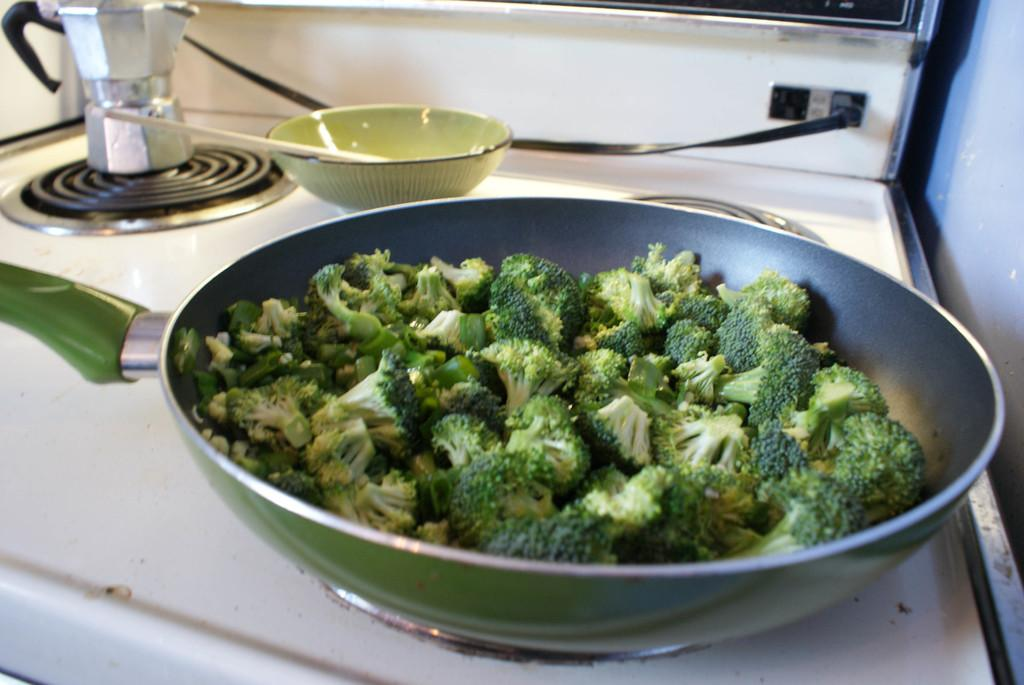What is in the pan that is visible in the image? There are vegetable pieces in a pan. Where is the pan located in the image? The pan is on a stove. What type of bears can be seen interacting with the vegetable pieces in the pan? There are no bears present in the image; it features a pan with vegetable pieces on a stove. What type of plough is used to prepare the vegetables in the pan? There is no plough present in the image; it features a pan with vegetable pieces on a stove. 